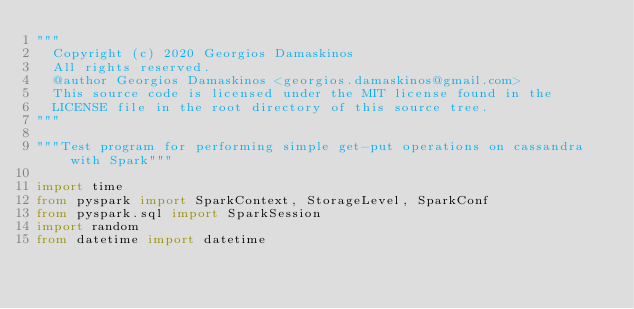Convert code to text. <code><loc_0><loc_0><loc_500><loc_500><_Python_>"""
  Copyright (c) 2020 Georgios Damaskinos
  All rights reserved.
  @author Georgios Damaskinos <georgios.damaskinos@gmail.com>
  This source code is licensed under the MIT license found in the
  LICENSE file in the root directory of this source tree.
"""

"""Test program for performing simple get-put operations on cassandra with Spark"""

import time
from pyspark import SparkContext, StorageLevel, SparkConf
from pyspark.sql import SparkSession
import random
from datetime import datetime</code> 